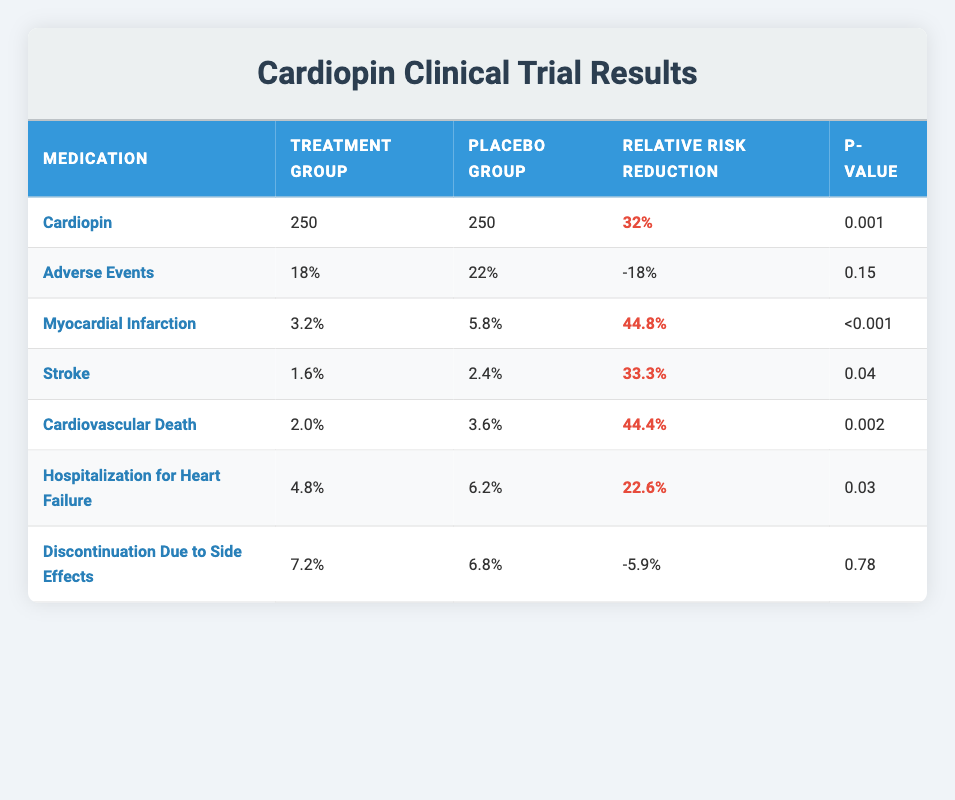What is the relative risk reduction for Cardiopin? In the table, under the column "Relative Risk Reduction" for Cardiopin, it states 32%. This indicates the percentage reduction in the risk of certain cardiac events when treated with Cardiopin compared to the placebo.
Answer: 32% What is the P-value for Myocardial Infarction? The row corresponding to Myocardial Infarction shows a P-value of less than 0.001. This implies a highly statistically significant result for the effect of the medication compared to the placebo group.
Answer: <0.001 Which event has the highest relative risk reduction? By reviewing the "Relative Risk Reduction" values, Myocardial Infarction has the highest relative risk reduction of 44.8%, which is greater than the other values listed.
Answer: 44.8% Is the P-value for stroke statistically significant? The P-value for stroke is 0.04. Since it is less than 0.05, this indicates that the result is statistically significant.
Answer: Yes What is the difference in hospitalization for heart failure rates between the treatment and placebo groups? From the table, the hospitalization rate for heart failure in the treatment group is 4.8%, and in the placebo group, it is 6.2%. The difference is 6.2% - 4.8% = 1.4%, showing a lower rate in the treatment group.
Answer: 1.4% What percentage of participants experienced adverse events in the treatment group compared to the placebo group? The treatment group had 18% experiencing adverse events, while the placebo group had 22%. The difference indicates a lower occurrence in the treatment group.
Answer: Treatment: 18%, Placebo: 22% Which event had the highest rate in the placebo group? Upon examining all the events in the placebo group, the highest rate is for Adverse Events, which is 22%.
Answer: 22% How many participants had myocardial infarction in the treatment and placebo groups combined? The treatment group had 3.2% and the placebo group had 5.8% experiencing myocardial infarctions. Therefore, combined, this is 3.2% + 5.8% = 9%.
Answer: 9% What is the relative risk reduction for cardiovascular death in the trial? The relative risk reduction for cardiovascular death listed in the table is 44.4%, suggesting a significant improvement with the medication compared to the placebo.
Answer: 44.4% Is the rate of discontinuation due to side effects higher in the treatment group compared to the placebo group? The table shows that the treatment group has a discontinuation rate of 7.2% while the placebo group has 6.8%. Therefore, the treatment group has a higher rate.
Answer: Yes 